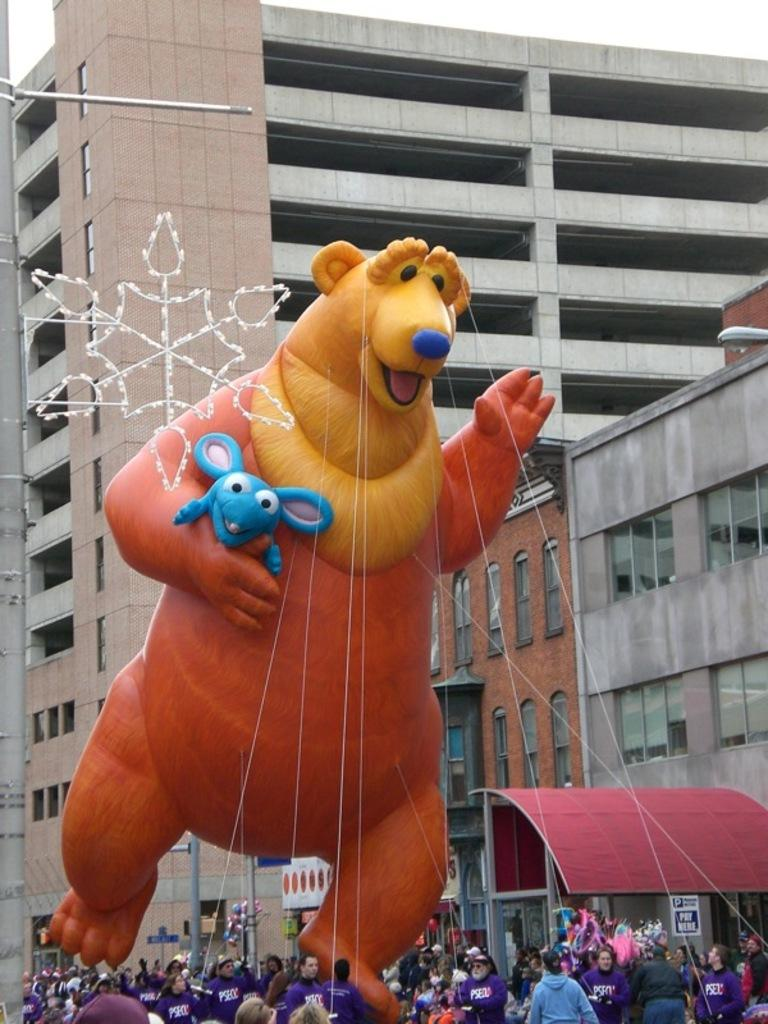What are the people holding in the image? The people are holding a gas balloon in the image. What is the shape of the gas balloon? The gas balloon has an animal structure. How is the gas balloon being held? The gas balloon is held with ropes. What can be seen in the background of the image? There are buildings and lamp posts visible in the background of the image. Can you see any destruction caused by a fork in the image? There is no fork or any indication of destruction present in the image. 